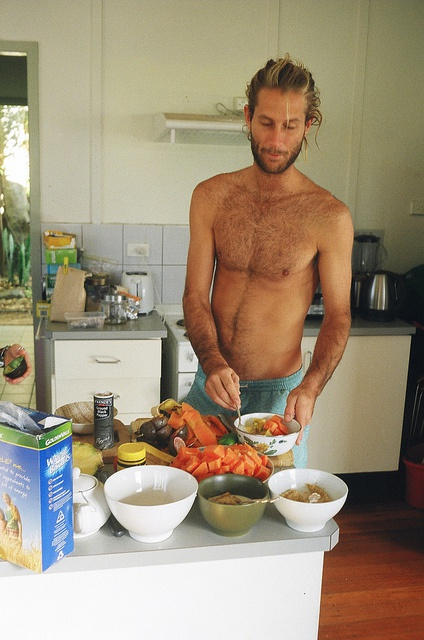Describe the objects in this image and their specific colors. I can see people in darkgray, brown, salmon, tan, and maroon tones, bowl in darkgray, lightgray, and tan tones, bowl in darkgray, lightgray, and tan tones, bowl in darkgray, gray, olive, darkgreen, and black tones, and bowl in darkgray, lightgray, tan, and brown tones in this image. 